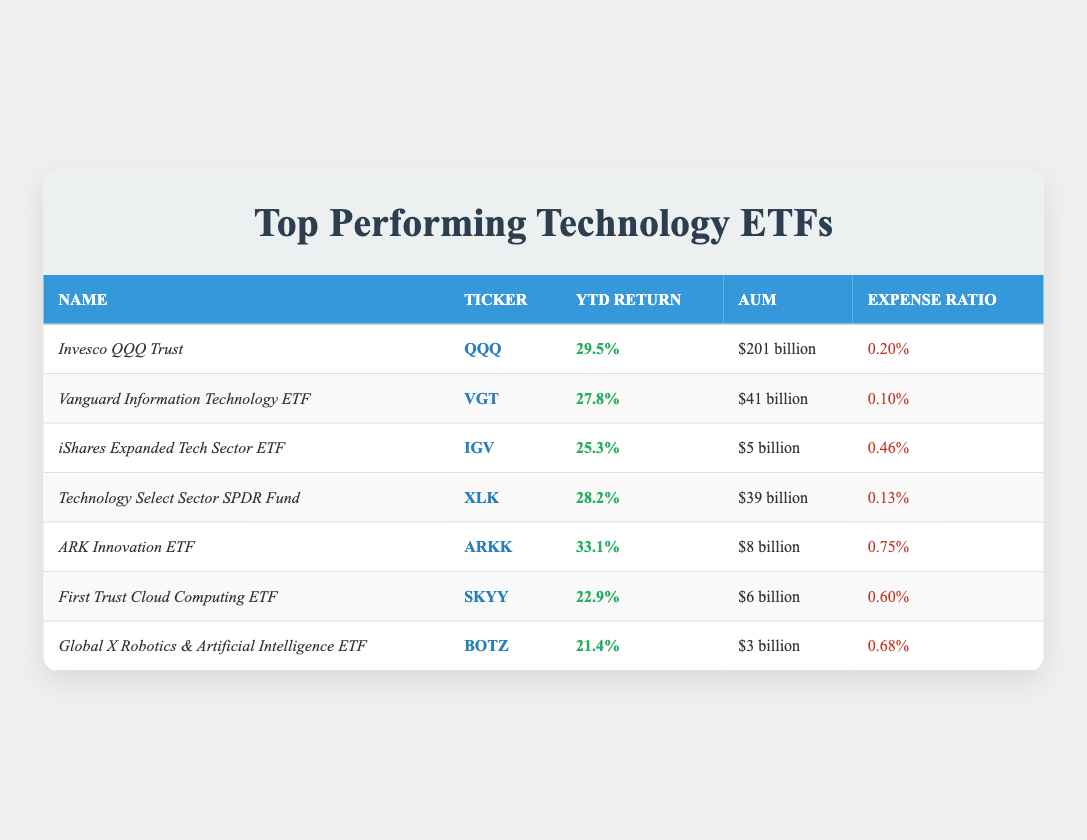What is the year-to-date return for the ARK Innovation ETF? The table shows the year-to-date return for the ARK Innovation ETF, which is listed as 33.1%.
Answer: 33.1% Which ETF has the lowest expense ratio? By examining the expense ratios in the table, the Vanguard Information Technology ETF has the lowest expense ratio at 0.10%.
Answer: 0.10% What is the total assets under management (AUM) for the top three ETFs by year-to-date return? The top three ETFs by year-to-date return are ARK Innovation ETF ($8 billion), Invesco QQQ Trust ($201 billion), and Technology Select Sector SPDR Fund ($39 billion). Summing these gives $8B + $201B + $39B = $248 billion.
Answer: $248 billion Is the year-to-date return for the iShares Expanded Tech Sector ETF greater than 25%? The year-to-date return for the iShares Expanded Tech Sector ETF is 25.3%, which is greater than 25%.
Answer: Yes What is the difference in year-to-date return between the Invesco QQQ Trust and the Vanguard Information Technology ETF? The Invesco QQQ Trust has a year-to-date return of 29.5% and the Vanguard Information Technology ETF has 27.8%. The difference is 29.5% - 27.8% = 1.7%.
Answer: 1.7% Which ETF has a higher year-to-date return, Technology Select Sector SPDR Fund or iShares Expanded Tech Sector ETF? The year-to-date return for the Technology Select Sector SPDR Fund is 28.2%, and for the iShares Expanded Tech Sector ETF it's 25.3%. Since 28.2% is greater than 25.3%, the Technology Select Sector SPDR Fund has the higher return.
Answer: Technology Select Sector SPDR Fund How many ETFs have a year-to-date return of over 25%? By reviewing the table, the ETFs with returns over 25% are: Invesco QQQ Trust (29.5%), Vanguard Information Technology ETF (27.8%), Technology Select Sector SPDR Fund (28.2%), and ARK Innovation ETF (33.1%). There are four ETFs total.
Answer: 4 What percentage of assets under management does the ARK Innovation ETF represent compared to the total AUM of the top performing ETFs? The total AUM of the listed ETFs is $201 + $41 + $5 + $39 + $8 + $6 + $3 = $303 billion. The AUM of the ARK Innovation ETF is $8 billion. The percentage is (8 / 303) * 100 = 2.64%.
Answer: 2.64% What is the average year-to-date return of all the ETFs listed? Adding the year-to-date returns (29.5 + 27.8 + 25.3 + 28.2 + 33.1 + 22.9 + 21.4) = 188.2%. Then dividing by 7 (the number of ETFs) gives an average of 188.2 / 7 = 26.74%.
Answer: 26.74% Which ETF listed has the highest assets under management? The Invesco QQQ Trust has the highest assets under management, stated as $201 billion in the table.
Answer: $201 billion 